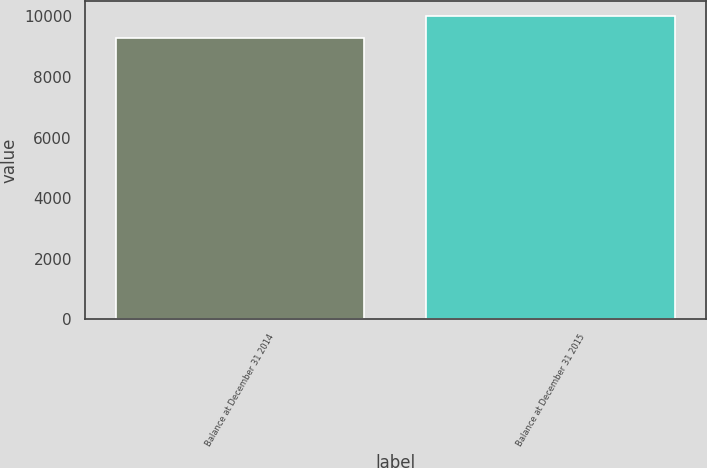Convert chart to OTSL. <chart><loc_0><loc_0><loc_500><loc_500><bar_chart><fcel>Balance at December 31 2014<fcel>Balance at December 31 2015<nl><fcel>9284<fcel>10019<nl></chart> 